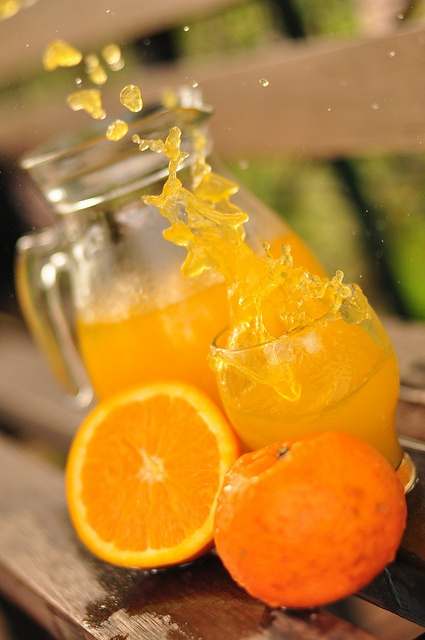Describe the objects in this image and their specific colors. I can see bench in tan, gray, maroon, and brown tones, orange in tan, orange, and gold tones, orange in tan, red, orange, and brown tones, and cup in tan, orange, and red tones in this image. 